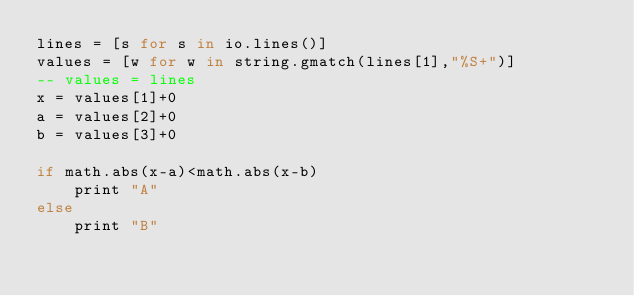Convert code to text. <code><loc_0><loc_0><loc_500><loc_500><_MoonScript_>lines = [s for s in io.lines()]
values = [w for w in string.gmatch(lines[1],"%S+")]
-- values = lines
x = values[1]+0
a = values[2]+0
b = values[3]+0

if math.abs(x-a)<math.abs(x-b)
	print "A"
else
	print "B"</code> 